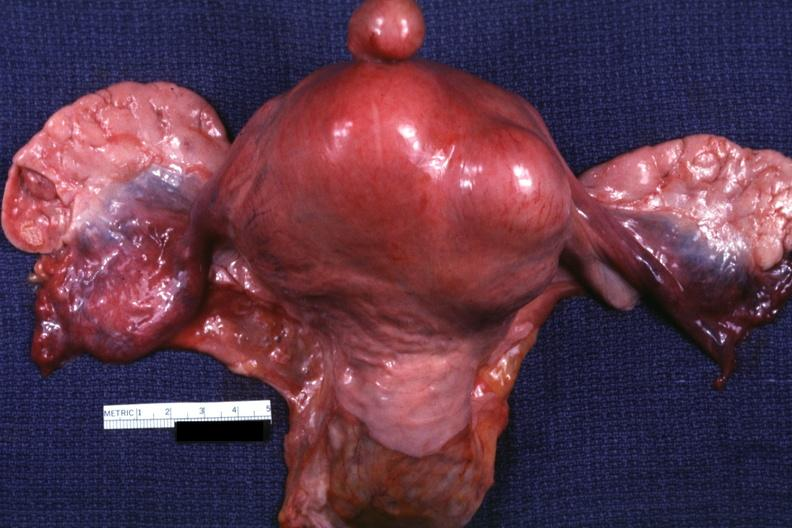s this a good example one pedunculated myoma?
Answer the question using a single word or phrase. Yes 